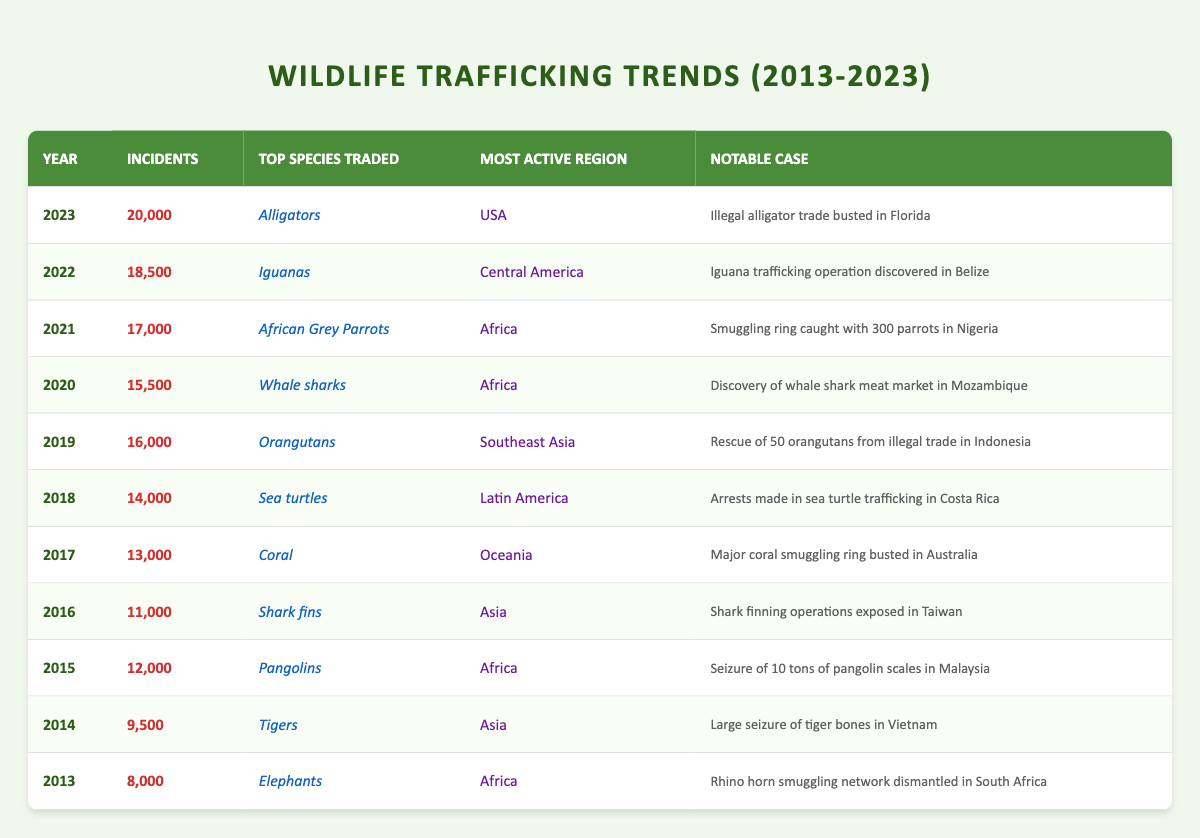What was the top species traded in 2020? According to the table, in 2020, the top species traded was "Whale sharks."
Answer: Whale sharks In which year were the most wildlife trafficking incidents reported? By examining the number of incidents column, 2023 shows the highest number of incidents at 20,000.
Answer: 2023 How many incidents were reported in 2016? The table indicates that in 2016, there were 11,000 incidents reported.
Answer: 11,000 What is the average number of incidents per year from 2013 to 2023? First, we sum the incidents from each year: 8000 + 9500 + 12000 + 11000 + 13000 + 14000 + 16000 + 15500 + 17000 + 18500 + 20000 = 139000. Then, divide by 11 (the number of years): 139000 / 11 ≈ 12636.36.
Answer: 12636.36 Was there a year where the number of incidents decreased compared to the previous year? No, the table shows an upward trend in the number of incidents each year from 2013 to 2023.
Answer: No Which region was most active in wildlife trafficking in 2017? The information in the table shows that Oceania was the most active region in 2017.
Answer: Oceania What notable case occurred in 2019? The notable case for 2019, as per the table, was the "Rescue of 50 orangutans from illegal trade in Indonesia."
Answer: Rescue of 50 orangutans How many more incidents were reported in 2022 than in 2020? We compare the incidents reported: 2022 had 18,500 incidents and 2020 had 15,500 incidents. The difference is 18500 - 15500 = 3000.
Answer: 3000 What was the most active region in wildlife trafficking in 2023? According to the table, the most active region in 2023 was the USA.
Answer: USA 